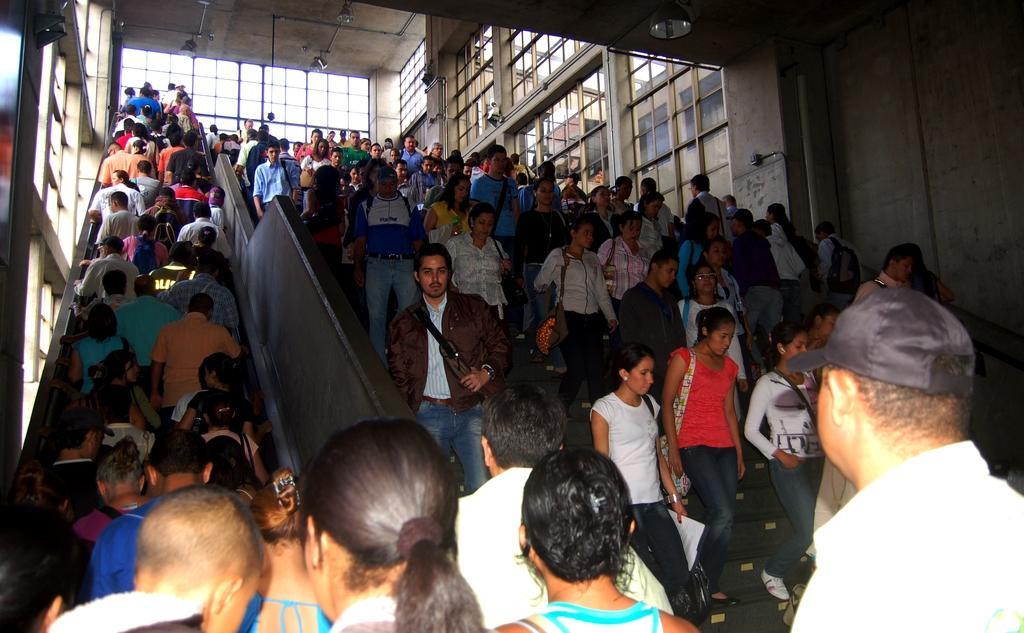Can you describe this image briefly? In this image I can see some people on the stairs. On the left and right side, I can see the windows. At the top I can see the lights. 